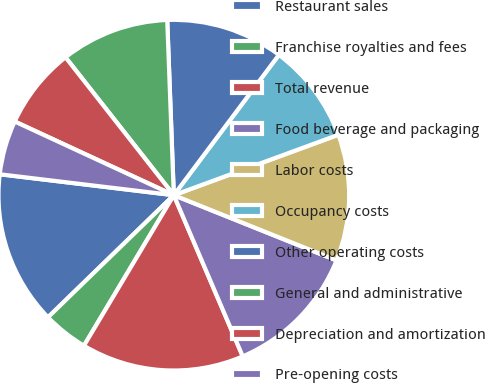Convert chart. <chart><loc_0><loc_0><loc_500><loc_500><pie_chart><fcel>Restaurant sales<fcel>Franchise royalties and fees<fcel>Total revenue<fcel>Food beverage and packaging<fcel>Labor costs<fcel>Occupancy costs<fcel>Other operating costs<fcel>General and administrative<fcel>Depreciation and amortization<fcel>Pre-opening costs<nl><fcel>14.17%<fcel>4.17%<fcel>15.0%<fcel>12.5%<fcel>11.67%<fcel>9.17%<fcel>10.83%<fcel>10.0%<fcel>7.5%<fcel>5.0%<nl></chart> 